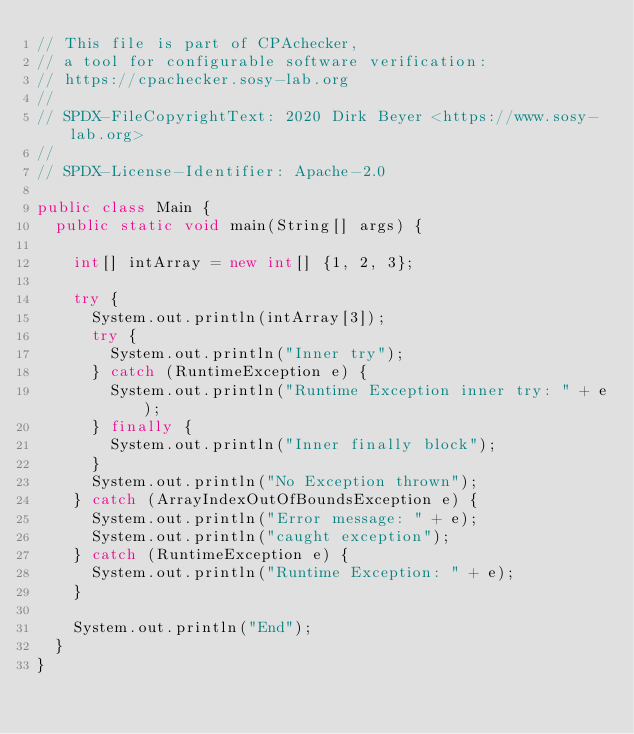<code> <loc_0><loc_0><loc_500><loc_500><_Java_>// This file is part of CPAchecker,
// a tool for configurable software verification:
// https://cpachecker.sosy-lab.org
//
// SPDX-FileCopyrightText: 2020 Dirk Beyer <https://www.sosy-lab.org>
//
// SPDX-License-Identifier: Apache-2.0

public class Main {
  public static void main(String[] args) {

    int[] intArray = new int[] {1, 2, 3};

    try {
      System.out.println(intArray[3]);
      try {
        System.out.println("Inner try");
      } catch (RuntimeException e) {
        System.out.println("Runtime Exception inner try: " + e);
      } finally {
        System.out.println("Inner finally block");
      }
      System.out.println("No Exception thrown");
    } catch (ArrayIndexOutOfBoundsException e) {
      System.out.println("Error message: " + e);
      System.out.println("caught exception");
    } catch (RuntimeException e) {
      System.out.println("Runtime Exception: " + e);
    }

    System.out.println("End");
  }
}
</code> 